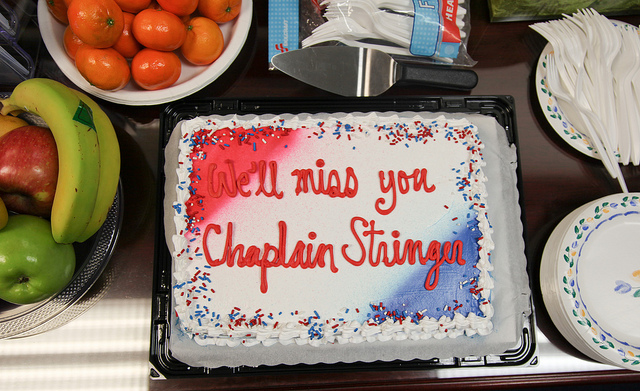Please transcribe the text in this image. We'll Miss you CHaplain Stringer 